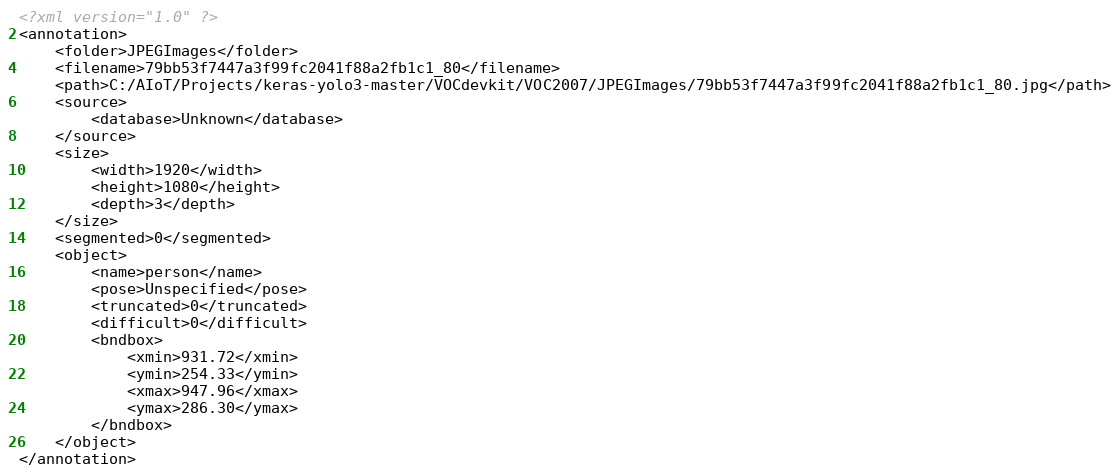<code> <loc_0><loc_0><loc_500><loc_500><_XML_><?xml version="1.0" ?>
<annotation>
	<folder>JPEGImages</folder>
	<filename>79bb53f7447a3f99fc2041f88a2fb1c1_80</filename>
	<path>C:/AIoT/Projects/keras-yolo3-master/VOCdevkit/VOC2007/JPEGImages/79bb53f7447a3f99fc2041f88a2fb1c1_80.jpg</path>
	<source>
		<database>Unknown</database>
	</source>
	<size>
		<width>1920</width>
		<height>1080</height>
		<depth>3</depth>
	</size>
	<segmented>0</segmented>
	<object>
		<name>person</name>
		<pose>Unspecified</pose>
		<truncated>0</truncated>
		<difficult>0</difficult>
		<bndbox>
			<xmin>931.72</xmin>
			<ymin>254.33</ymin>
			<xmax>947.96</xmax>
			<ymax>286.30</ymax>
		</bndbox>
	</object>
</annotation>
</code> 